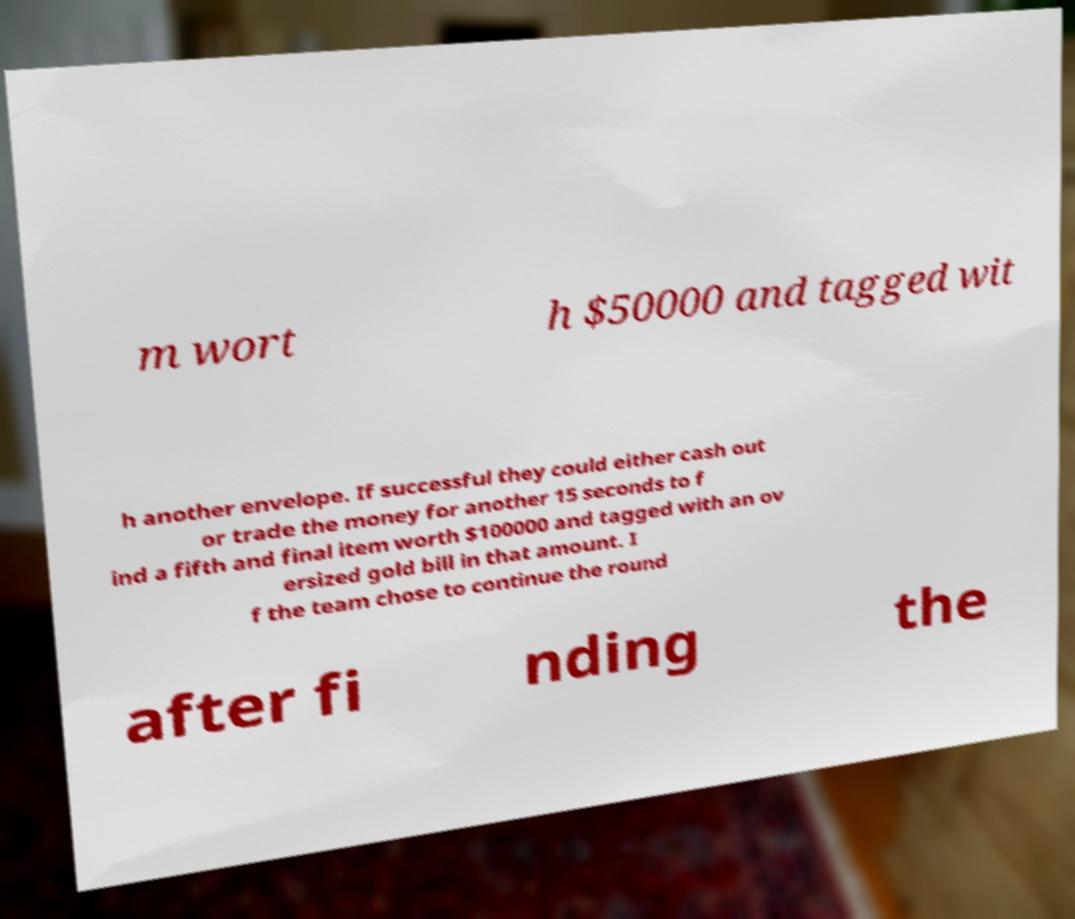Please identify and transcribe the text found in this image. m wort h $50000 and tagged wit h another envelope. If successful they could either cash out or trade the money for another 15 seconds to f ind a fifth and final item worth $100000 and tagged with an ov ersized gold bill in that amount. I f the team chose to continue the round after fi nding the 